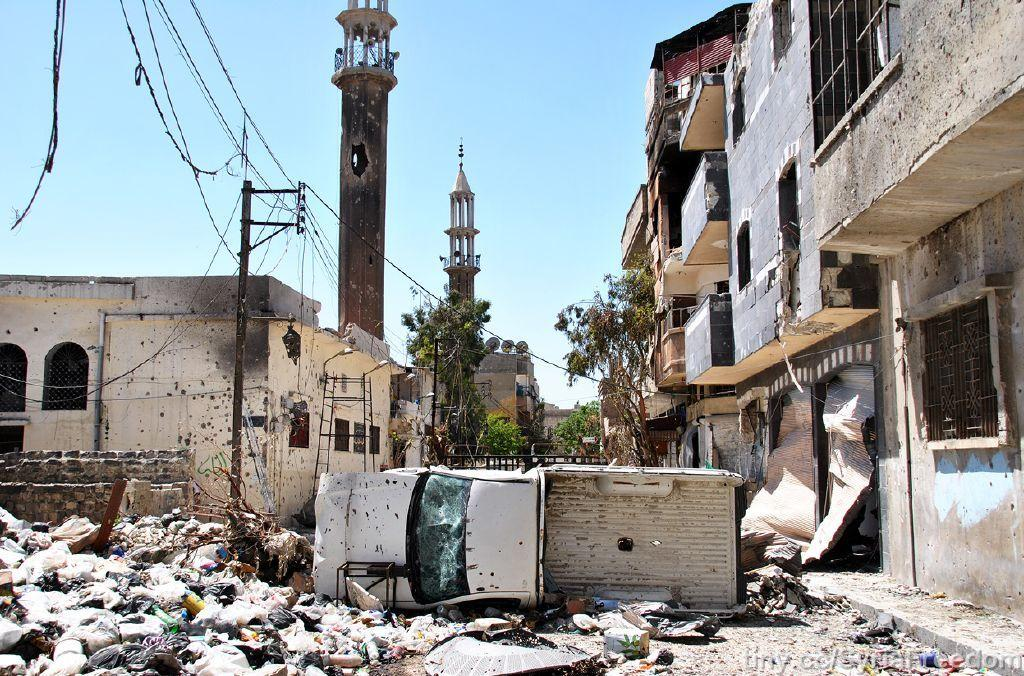What is happening to the buildings in the image? The buildings are under excavation in the image. What can be seen near the excavation site? There is a dumping yard in the image. What structures are visible in the image? There are towers in the image. What utility infrastructure is present in the image? Electric poles and electric cables are present in the image. What type of vegetation is visible in the image? There are trees in the image. What is visible in the background of the image? The sky is visible in the image. How does the territory of the birds change in the image? There are no birds or territories mentioned in the image; it features buildings under excavation, a dumping yard, towers, electric poles, electric cables, trees, and the sky. Can you see an airplane flying in the image? There is no airplane visible in the image. 